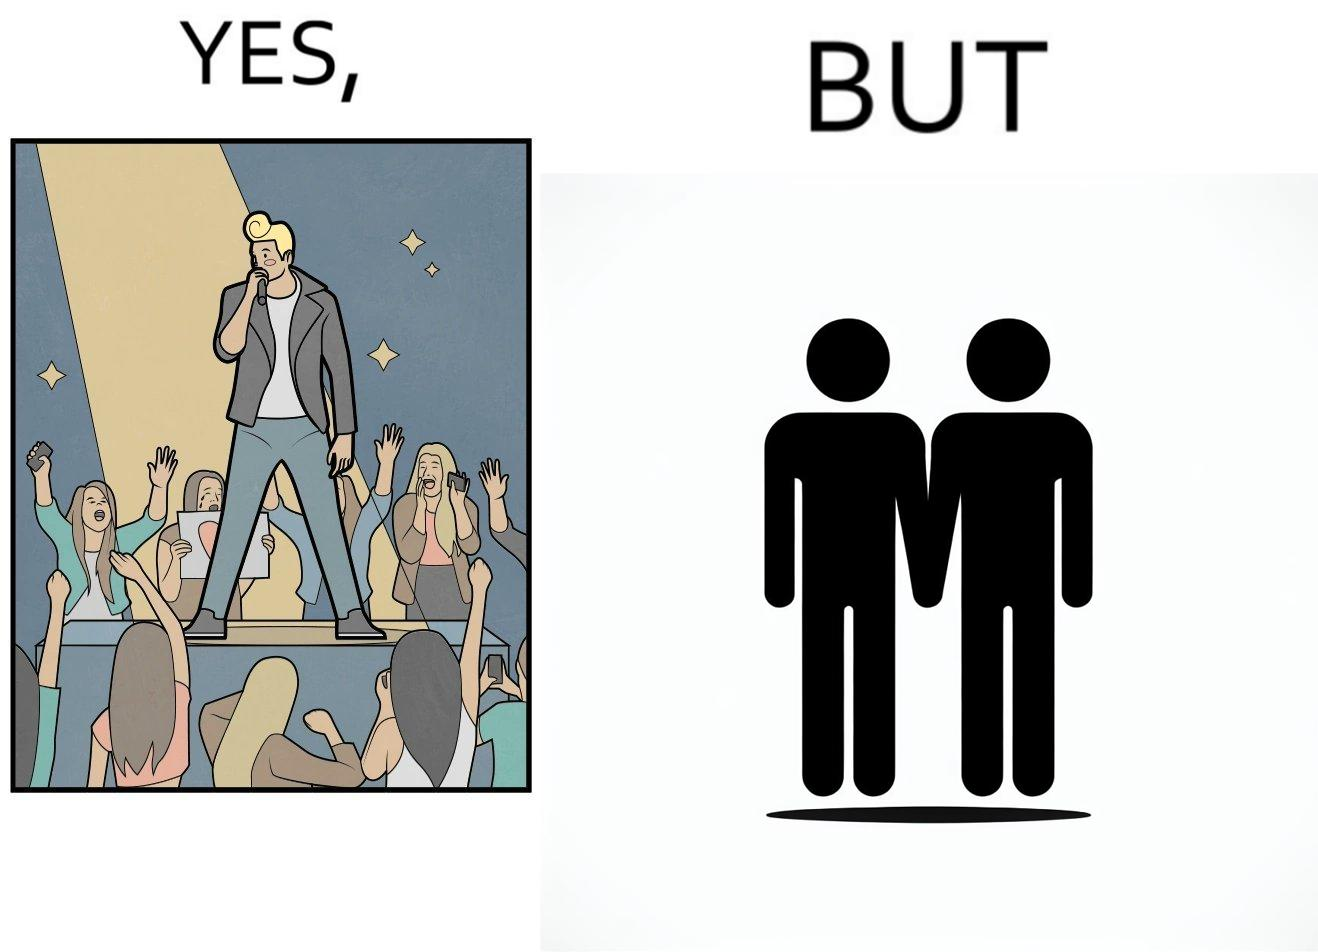Would you classify this image as satirical? Yes, this image is satirical. 